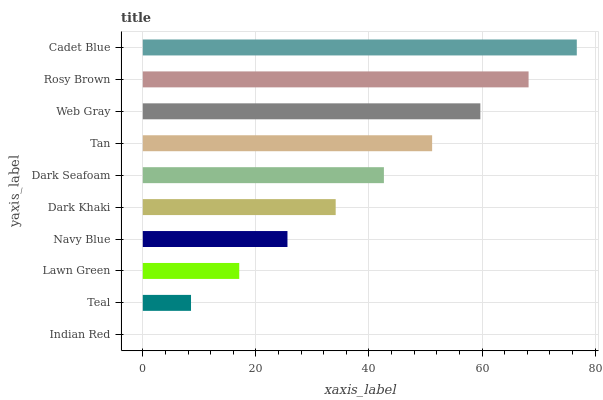Is Indian Red the minimum?
Answer yes or no. Yes. Is Cadet Blue the maximum?
Answer yes or no. Yes. Is Teal the minimum?
Answer yes or no. No. Is Teal the maximum?
Answer yes or no. No. Is Teal greater than Indian Red?
Answer yes or no. Yes. Is Indian Red less than Teal?
Answer yes or no. Yes. Is Indian Red greater than Teal?
Answer yes or no. No. Is Teal less than Indian Red?
Answer yes or no. No. Is Dark Seafoam the high median?
Answer yes or no. Yes. Is Dark Khaki the low median?
Answer yes or no. Yes. Is Navy Blue the high median?
Answer yes or no. No. Is Cadet Blue the low median?
Answer yes or no. No. 